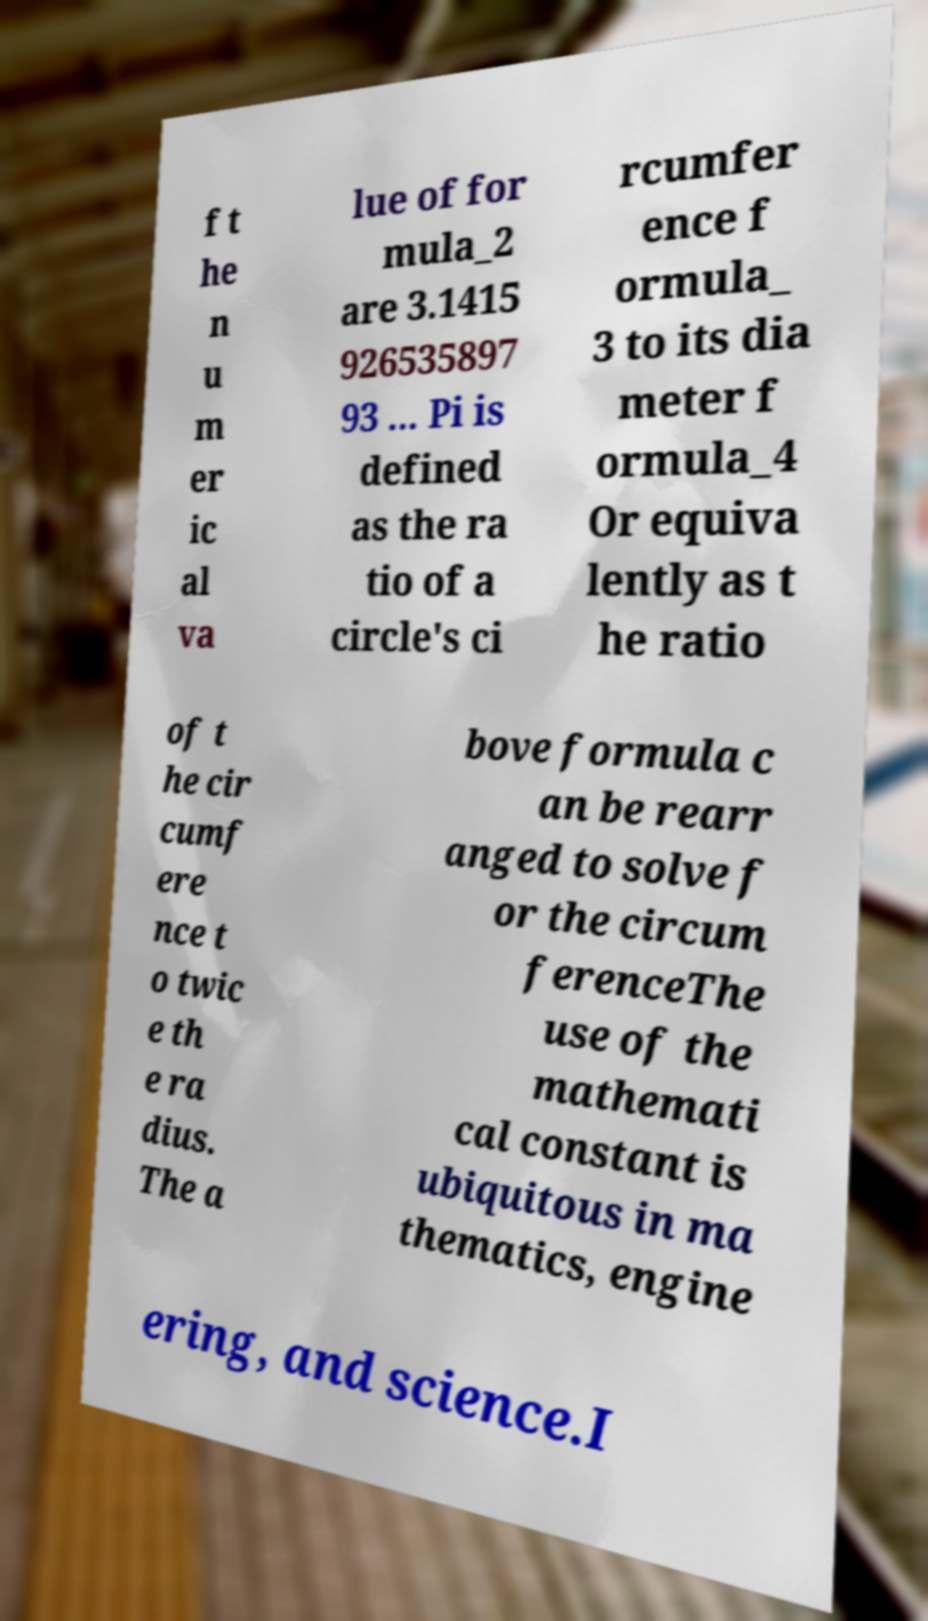Can you read and provide the text displayed in the image?This photo seems to have some interesting text. Can you extract and type it out for me? f t he n u m er ic al va lue of for mula_2 are 3.1415 926535897 93 ... Pi is defined as the ra tio of a circle's ci rcumfer ence f ormula_ 3 to its dia meter f ormula_4 Or equiva lently as t he ratio of t he cir cumf ere nce t o twic e th e ra dius. The a bove formula c an be rearr anged to solve f or the circum ferenceThe use of the mathemati cal constant is ubiquitous in ma thematics, engine ering, and science.I 